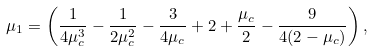<formula> <loc_0><loc_0><loc_500><loc_500>\mu _ { 1 } = \left ( \frac { 1 } { 4 \mu _ { c } ^ { 3 } } - \frac { 1 } { 2 \mu _ { c } ^ { 2 } } - \frac { 3 } { 4 \mu _ { c } } + 2 + \frac { \mu _ { c } } { 2 } - \frac { 9 } { 4 ( 2 - \mu _ { c } ) } \right ) ,</formula> 